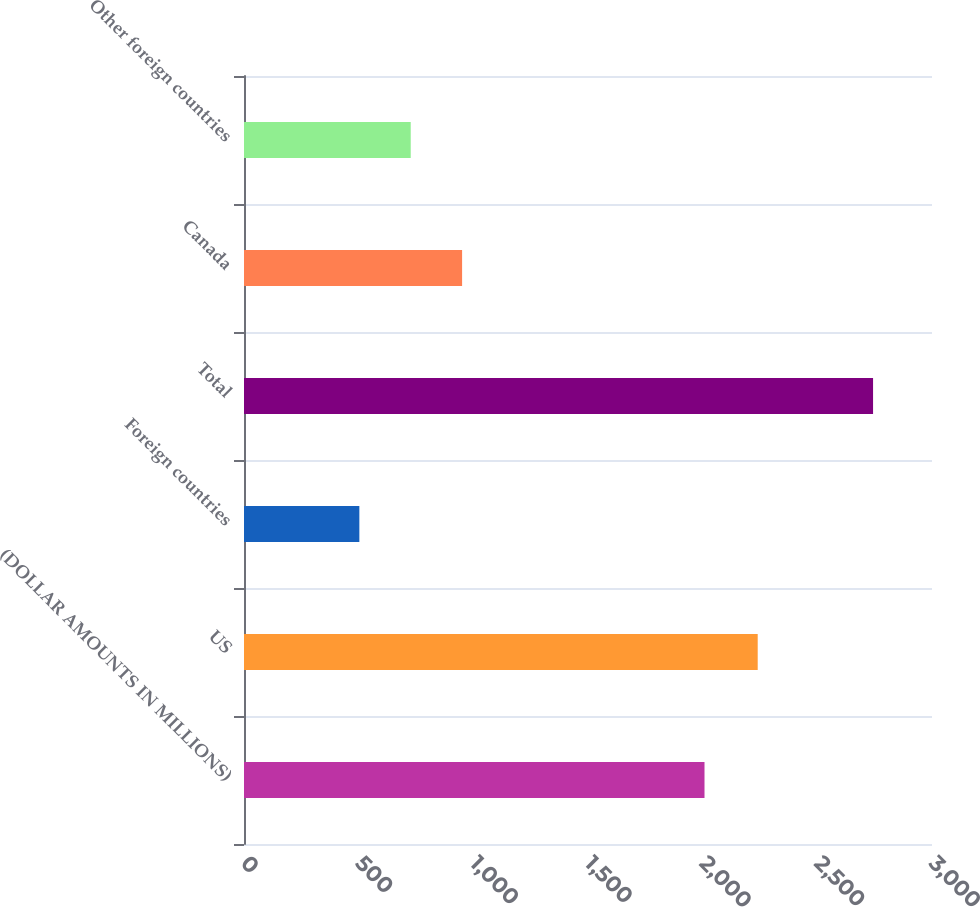<chart> <loc_0><loc_0><loc_500><loc_500><bar_chart><fcel>(DOLLAR AMOUNTS IN MILLIONS)<fcel>US<fcel>Foreign countries<fcel>Total<fcel>Canada<fcel>Other foreign countries<nl><fcel>2008<fcel>2240<fcel>503<fcel>2743<fcel>951<fcel>727<nl></chart> 